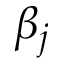Convert formula to latex. <formula><loc_0><loc_0><loc_500><loc_500>\beta _ { j }</formula> 